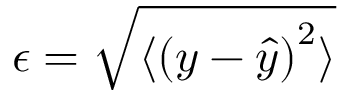<formula> <loc_0><loc_0><loc_500><loc_500>\epsilon = \sqrt { \langle { ( y - \hat { y } ) } ^ { 2 } \rangle }</formula> 